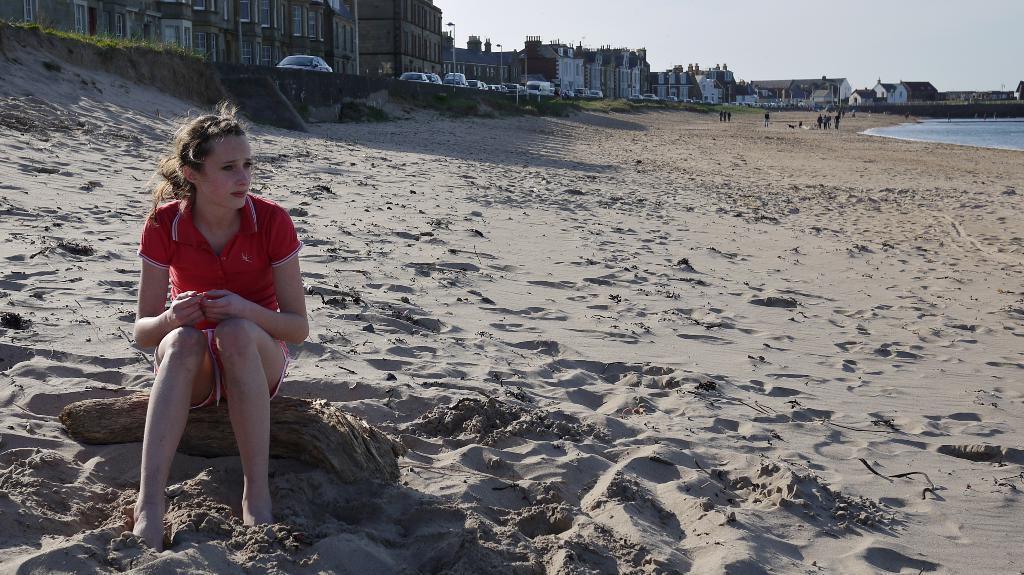Please provide a concise description of this image. In this image I can see the person sitting and the person is wearing red color shirt. Background I can see few vehicles, light poles, few buildings in white and brown color and I can also see the water and the sky is in white color. 